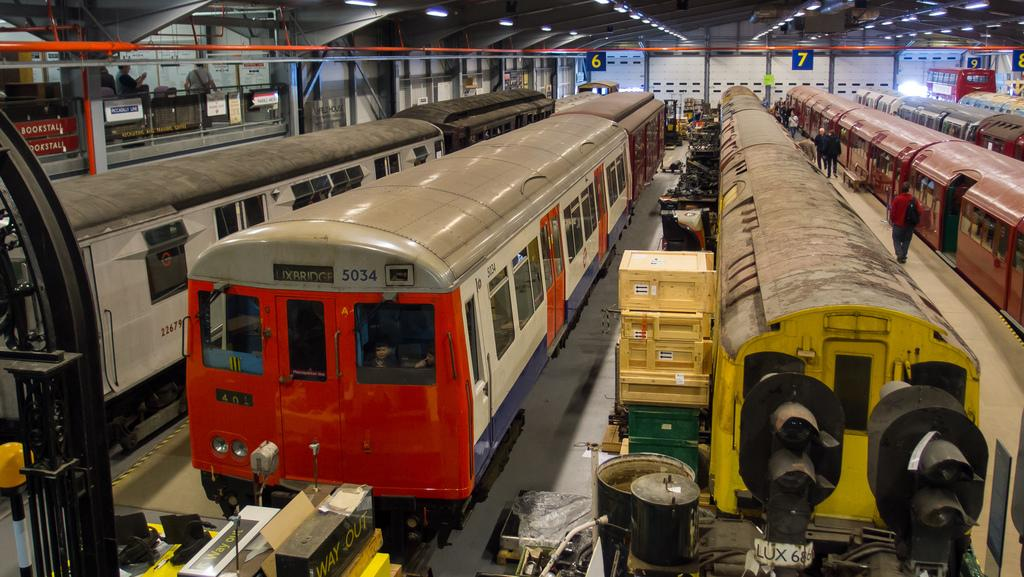What type of vehicles are on the railway tracks in the image? There are trains on the railway tracks in the image. Where are the people located in the image? People are standing on a platform in the image. What can be seen on the ceiling in the background of the image? There are lights on the ceiling visible in the background of the image. What other objects can be seen in the background of the image? There are other unspecified objects in the background of the image. What type of pencil is being used to draw on the shoe in the image? There is no pencil or shoe present in the image; it features trains on railway tracks and people on a platform. 